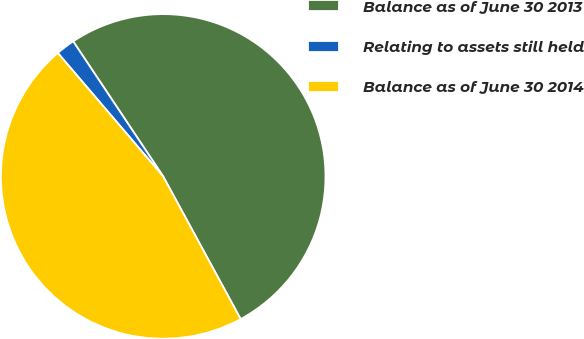Convert chart. <chart><loc_0><loc_0><loc_500><loc_500><pie_chart><fcel>Balance as of June 30 2013<fcel>Relating to assets still held<fcel>Balance as of June 30 2014<nl><fcel>51.43%<fcel>1.89%<fcel>46.67%<nl></chart> 